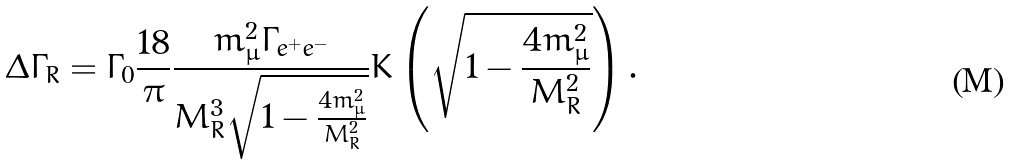Convert formula to latex. <formula><loc_0><loc_0><loc_500><loc_500>\Delta \Gamma _ { R } = \Gamma _ { 0 } \frac { 1 8 } { \pi } \frac { m _ { \mu } ^ { 2 } \Gamma _ { e ^ { + } e ^ { - } } } { M _ { R } ^ { 3 } \sqrt { 1 - \frac { 4 m _ { \mu } ^ { 2 } } { M _ { R } ^ { 2 } } } } K \left ( \sqrt { 1 - \frac { 4 m _ { \mu } ^ { 2 } } { M _ { R } ^ { 2 } } } \right ) .</formula> 